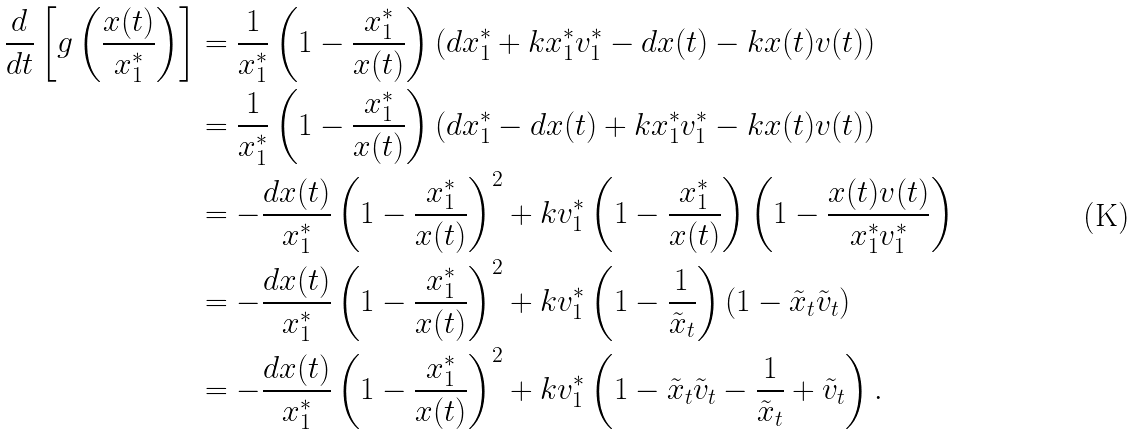<formula> <loc_0><loc_0><loc_500><loc_500>\frac { d } { d t } \left [ g \left ( \frac { x ( t ) } { x _ { 1 } ^ { * } } \right ) \right ] & = \frac { 1 } { x _ { 1 } ^ { * } } \left ( 1 - \frac { x _ { 1 } ^ { * } } { x ( t ) } \right ) \left ( d x _ { 1 } ^ { * } + k x _ { 1 } ^ { * } v _ { 1 } ^ { * } - d x ( t ) - k x ( t ) v ( t ) \right ) \\ & = \frac { 1 } { x _ { 1 } ^ { * } } \left ( 1 - \frac { x _ { 1 } ^ { * } } { x ( t ) } \right ) \left ( d x _ { 1 } ^ { * } - d x ( t ) + k x _ { 1 } ^ { * } v _ { 1 } ^ { * } - k x ( t ) v ( t ) \right ) \\ & = - \frac { d x ( t ) } { x _ { 1 } ^ { * } } \left ( 1 - \frac { x _ { 1 } ^ { * } } { x ( t ) } \right ) ^ { 2 } + k v _ { 1 } ^ { * } \left ( 1 - \frac { x _ { 1 } ^ { * } } { x ( t ) } \right ) \left ( 1 - \frac { x ( t ) v ( t ) } { x _ { 1 } ^ { * } v _ { 1 } ^ { * } } \right ) \\ & = - \frac { d x ( t ) } { x _ { 1 } ^ { * } } \left ( 1 - \frac { x _ { 1 } ^ { * } } { x ( t ) } \right ) ^ { 2 } + k v _ { 1 } ^ { * } \left ( 1 - \frac { 1 } { \tilde { x } _ { t } } \right ) \left ( 1 - \tilde { x } _ { t } \tilde { v } _ { t } \right ) \\ & = - \frac { d x ( t ) } { x _ { 1 } ^ { * } } \left ( 1 - \frac { x _ { 1 } ^ { * } } { x ( t ) } \right ) ^ { 2 } + k v _ { 1 } ^ { * } \left ( 1 - \tilde { x } _ { t } \tilde { v } _ { t } - \frac { 1 } { \tilde { x } _ { t } } + \tilde { v } _ { t } \right ) .</formula> 